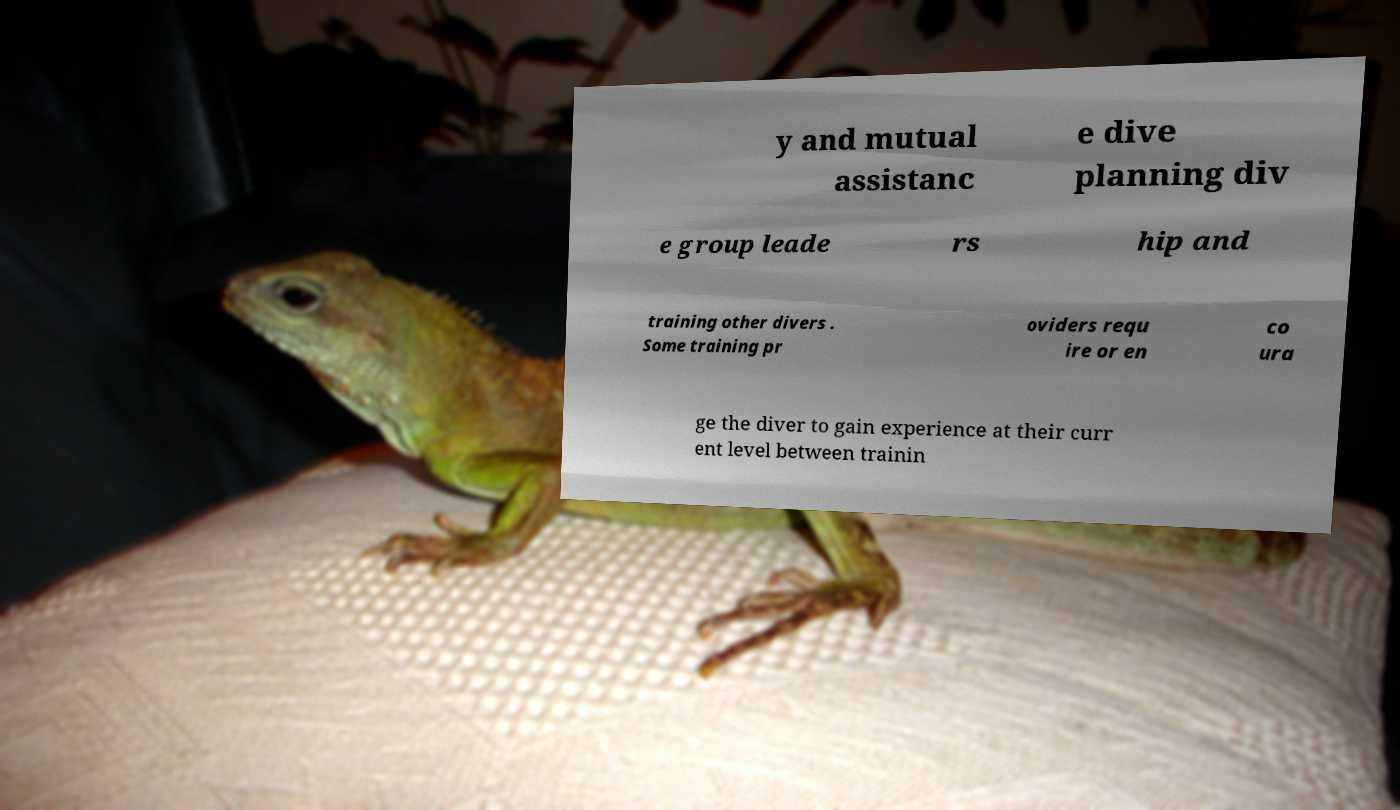Please identify and transcribe the text found in this image. y and mutual assistanc e dive planning div e group leade rs hip and training other divers . Some training pr oviders requ ire or en co ura ge the diver to gain experience at their curr ent level between trainin 